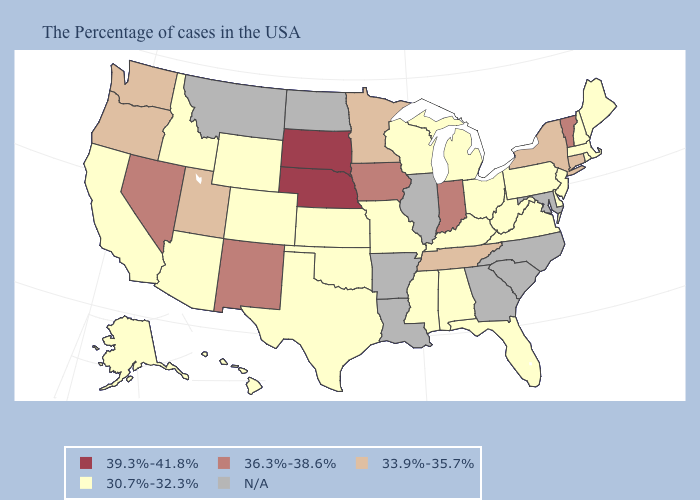What is the value of Oklahoma?
Be succinct. 30.7%-32.3%. What is the value of Tennessee?
Keep it brief. 33.9%-35.7%. What is the value of Louisiana?
Quick response, please. N/A. Does Florida have the lowest value in the USA?
Write a very short answer. Yes. What is the lowest value in the West?
Quick response, please. 30.7%-32.3%. What is the value of Oklahoma?
Keep it brief. 30.7%-32.3%. Name the states that have a value in the range N/A?
Keep it brief. Maryland, North Carolina, South Carolina, Georgia, Illinois, Louisiana, Arkansas, North Dakota, Montana. What is the value of New Hampshire?
Concise answer only. 30.7%-32.3%. What is the value of Ohio?
Concise answer only. 30.7%-32.3%. What is the lowest value in the USA?
Write a very short answer. 30.7%-32.3%. What is the value of Wisconsin?
Quick response, please. 30.7%-32.3%. What is the value of Indiana?
Be succinct. 36.3%-38.6%. Name the states that have a value in the range 33.9%-35.7%?
Answer briefly. Connecticut, New York, Tennessee, Minnesota, Utah, Washington, Oregon. What is the value of Virginia?
Concise answer only. 30.7%-32.3%. 